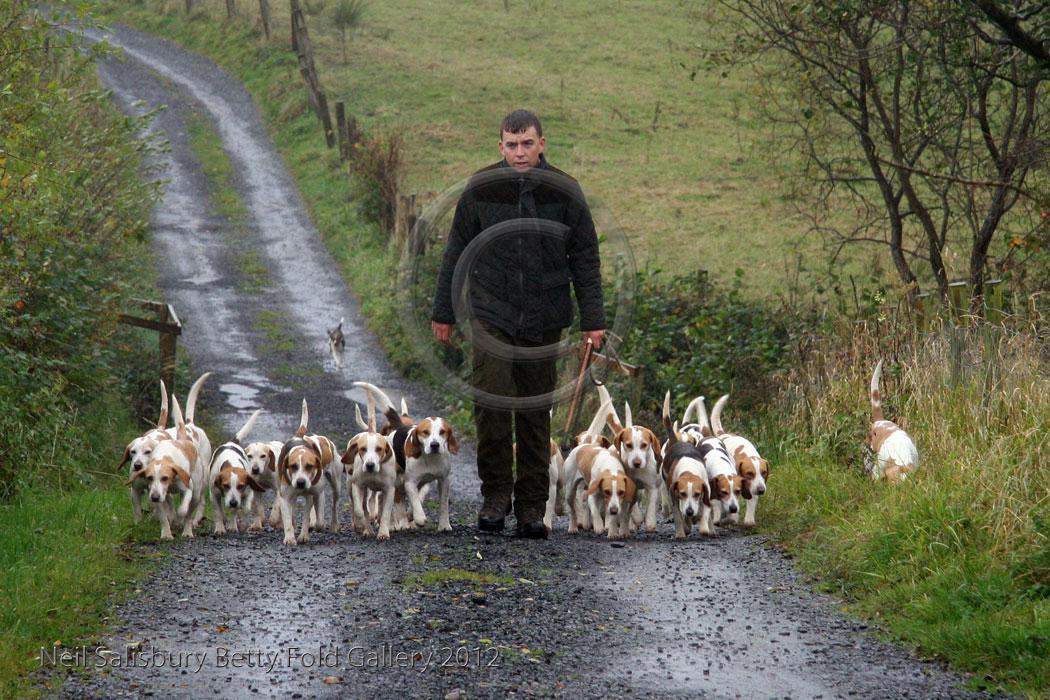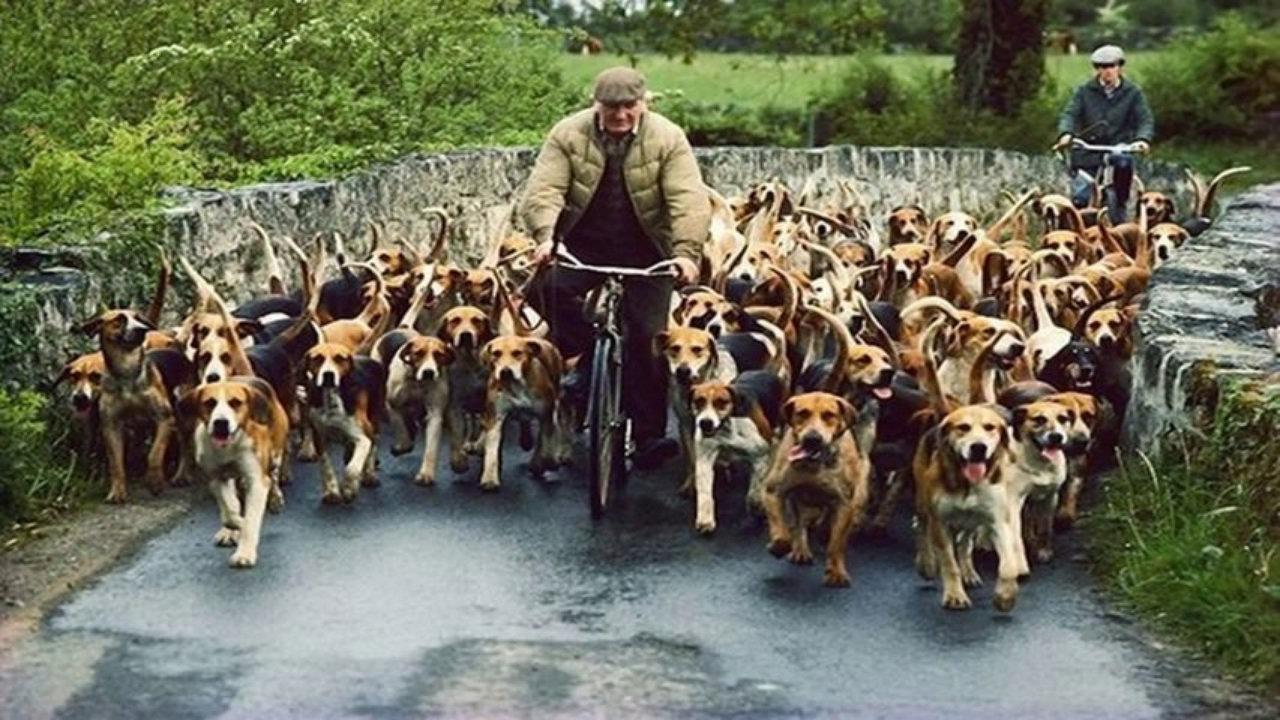The first image is the image on the left, the second image is the image on the right. Evaluate the accuracy of this statement regarding the images: "There are dogs and horses.". Is it true? Answer yes or no. No. The first image is the image on the left, the second image is the image on the right. Analyze the images presented: Is the assertion "An image contains a large herd of dogs following a man on a horse that is wearing a red jacket." valid? Answer yes or no. No. 